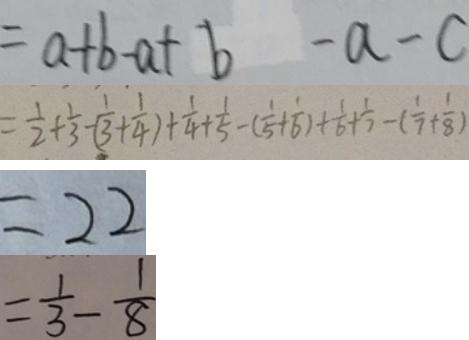<formula> <loc_0><loc_0><loc_500><loc_500>= a + b - a + b - a - c 
 = \frac { 1 } { 2 } + \frac { 1 } { 3 } - ( \frac { 1 } { 3 } + \frac { 1 } { 4 } ) + \frac { 1 } { 4 } + \frac { 1 } { 5 } - ( \frac { 1 } { 5 } + \frac { 1 } { 6 } ) + \frac { 1 } { 6 } + \frac { 1 } { 7 } - ( \frac { 1 } { 7 } + \frac { 1 } { 8 } ) 
 = 2 2 
 = \frac { 1 } { 3 } - \frac { 1 } { 8 }</formula> 